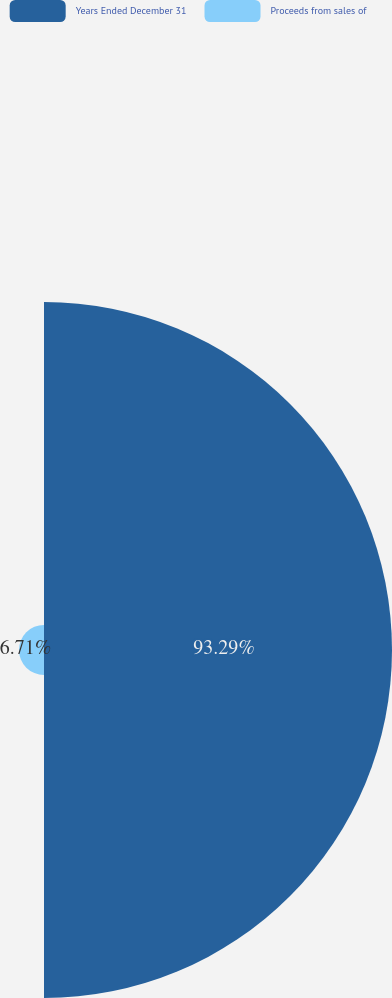Convert chart to OTSL. <chart><loc_0><loc_0><loc_500><loc_500><pie_chart><fcel>Years Ended December 31<fcel>Proceeds from sales of<nl><fcel>93.29%<fcel>6.71%<nl></chart> 